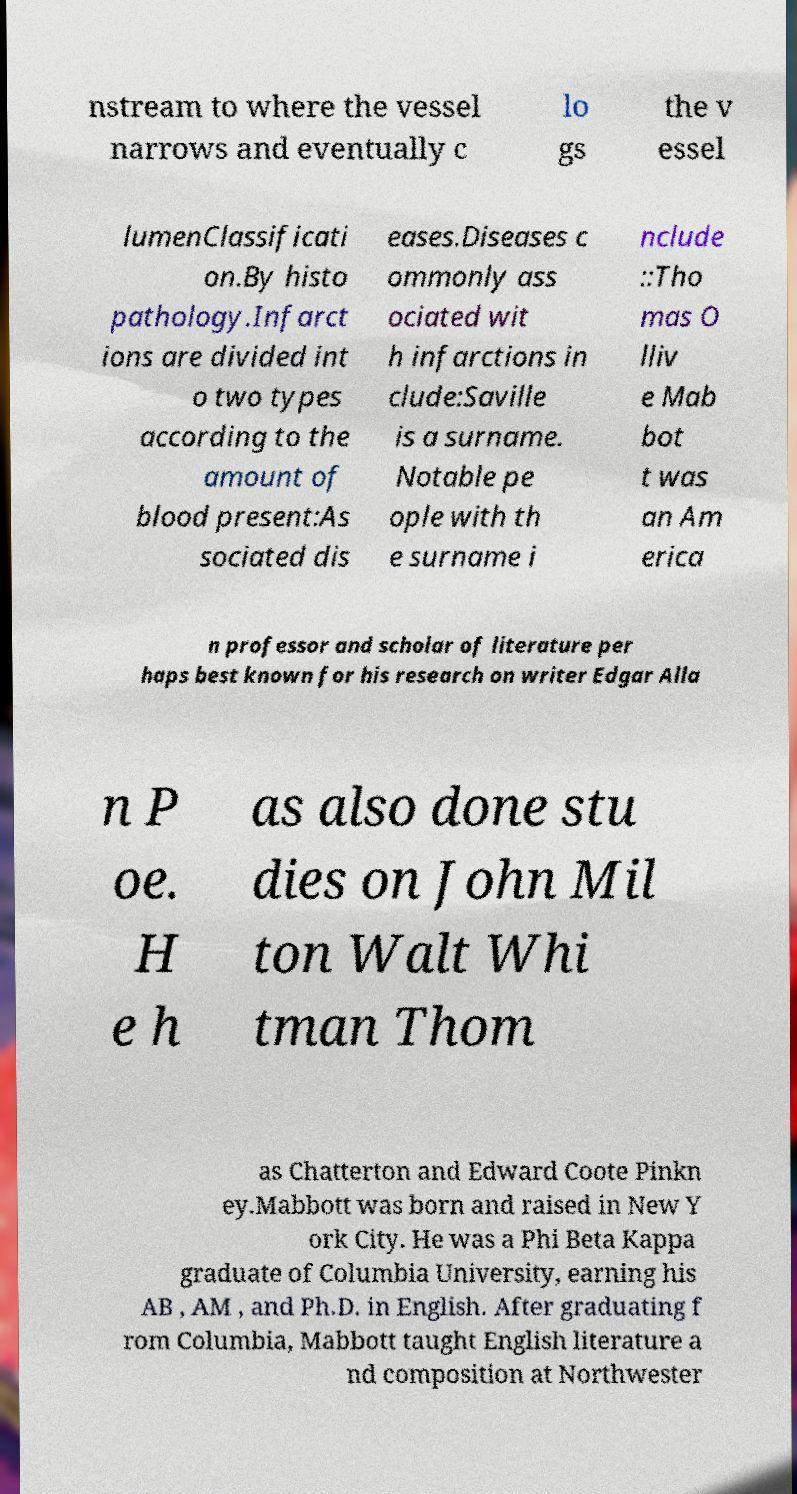What messages or text are displayed in this image? I need them in a readable, typed format. nstream to where the vessel narrows and eventually c lo gs the v essel lumenClassificati on.By histo pathology.Infarct ions are divided int o two types according to the amount of blood present:As sociated dis eases.Diseases c ommonly ass ociated wit h infarctions in clude:Saville is a surname. Notable pe ople with th e surname i nclude ::Tho mas O lliv e Mab bot t was an Am erica n professor and scholar of literature per haps best known for his research on writer Edgar Alla n P oe. H e h as also done stu dies on John Mil ton Walt Whi tman Thom as Chatterton and Edward Coote Pinkn ey.Mabbott was born and raised in New Y ork City. He was a Phi Beta Kappa graduate of Columbia University, earning his AB , AM , and Ph.D. in English. After graduating f rom Columbia, Mabbott taught English literature a nd composition at Northwester 